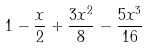<formula> <loc_0><loc_0><loc_500><loc_500>1 - \frac { x } { 2 } + \frac { 3 x ^ { 2 } } { 8 } - \frac { 5 x ^ { 3 } } { 1 6 }</formula> 